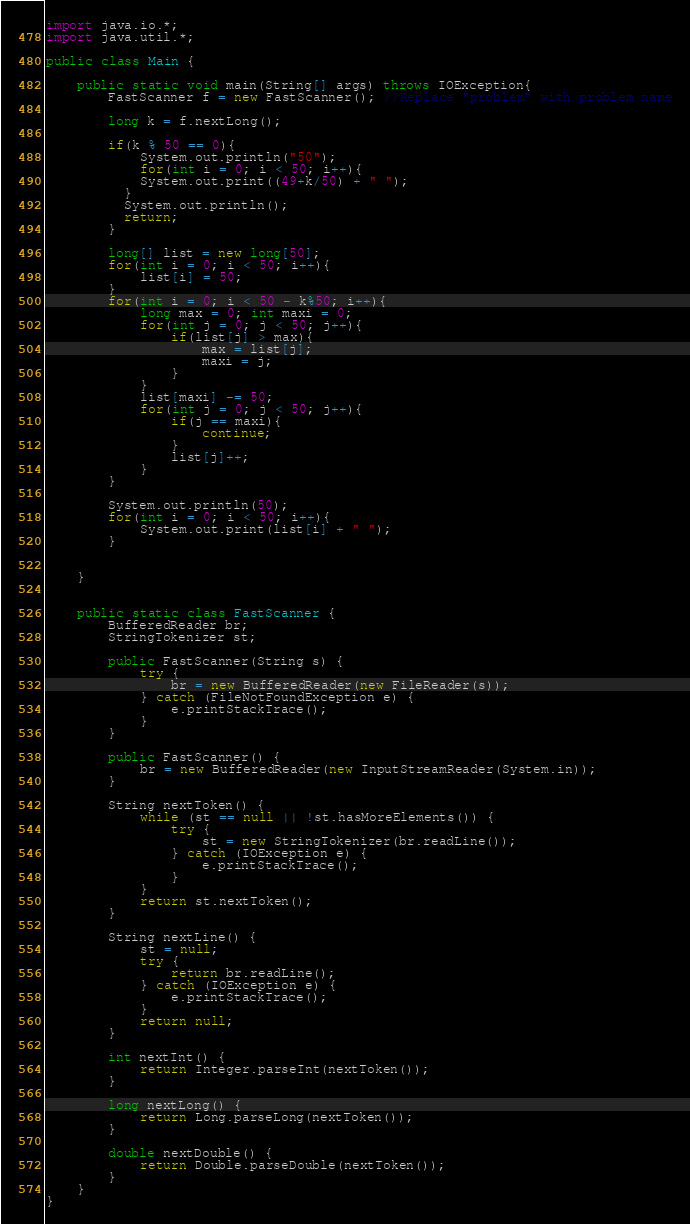Convert code to text. <code><loc_0><loc_0><loc_500><loc_500><_Java_>import java.io.*;
import java.util.*;

public class Main {

	public static void main(String[] args) throws IOException{
		FastScanner f = new FastScanner(); //Replace "problem" with problem name
        
        long k = f.nextLong();
        
        if(k % 50 == 0){
        	System.out.println("50");
        	for(int i = 0; i < 50; i++){
            System.out.print((49+k/50) + " ");
          }
          System.out.println();
          return;
        }
        
        long[] list = new long[50];
        for(int i = 0; i < 50; i++){
        	list[i] = 50;
        }
        for(int i = 0; i < 50 - k%50; i++){
        	long max = 0; int maxi = 0;
        	for(int j = 0; j < 50; j++){
        		if(list[j] > max){
        			max = list[j];
        			maxi = j;
        		}
        	}
        	list[maxi] -= 50;
        	for(int j = 0; j < 50; j++){
        		if(j == maxi){
        			continue;
        		}
        		list[j]++;
        	}
        }
        
        System.out.println(50);
        for(int i = 0; i < 50; i++){
        	System.out.print(list[i] + " ");
        }
        
        
	}


	public static class FastScanner {
        BufferedReader br;
        StringTokenizer st;

        public FastScanner(String s) {
            try {
                br = new BufferedReader(new FileReader(s));
            } catch (FileNotFoundException e) {
                e.printStackTrace();
            }
        }

        public FastScanner() {
            br = new BufferedReader(new InputStreamReader(System.in));
        }

        String nextToken() {
            while (st == null || !st.hasMoreElements()) {
                try {
                    st = new StringTokenizer(br.readLine());
                } catch (IOException e) {
                    e.printStackTrace();
                }
            }
            return st.nextToken();
        }

        String nextLine() {
            st = null;
            try {
                return br.readLine();
            } catch (IOException e) {
                e.printStackTrace();
            }
            return null;
        }

        int nextInt() {
            return Integer.parseInt(nextToken());
        }

        long nextLong() {
            return Long.parseLong(nextToken());
        }

        double nextDouble() {
            return Double.parseDouble(nextToken());
        }
    }
}
</code> 